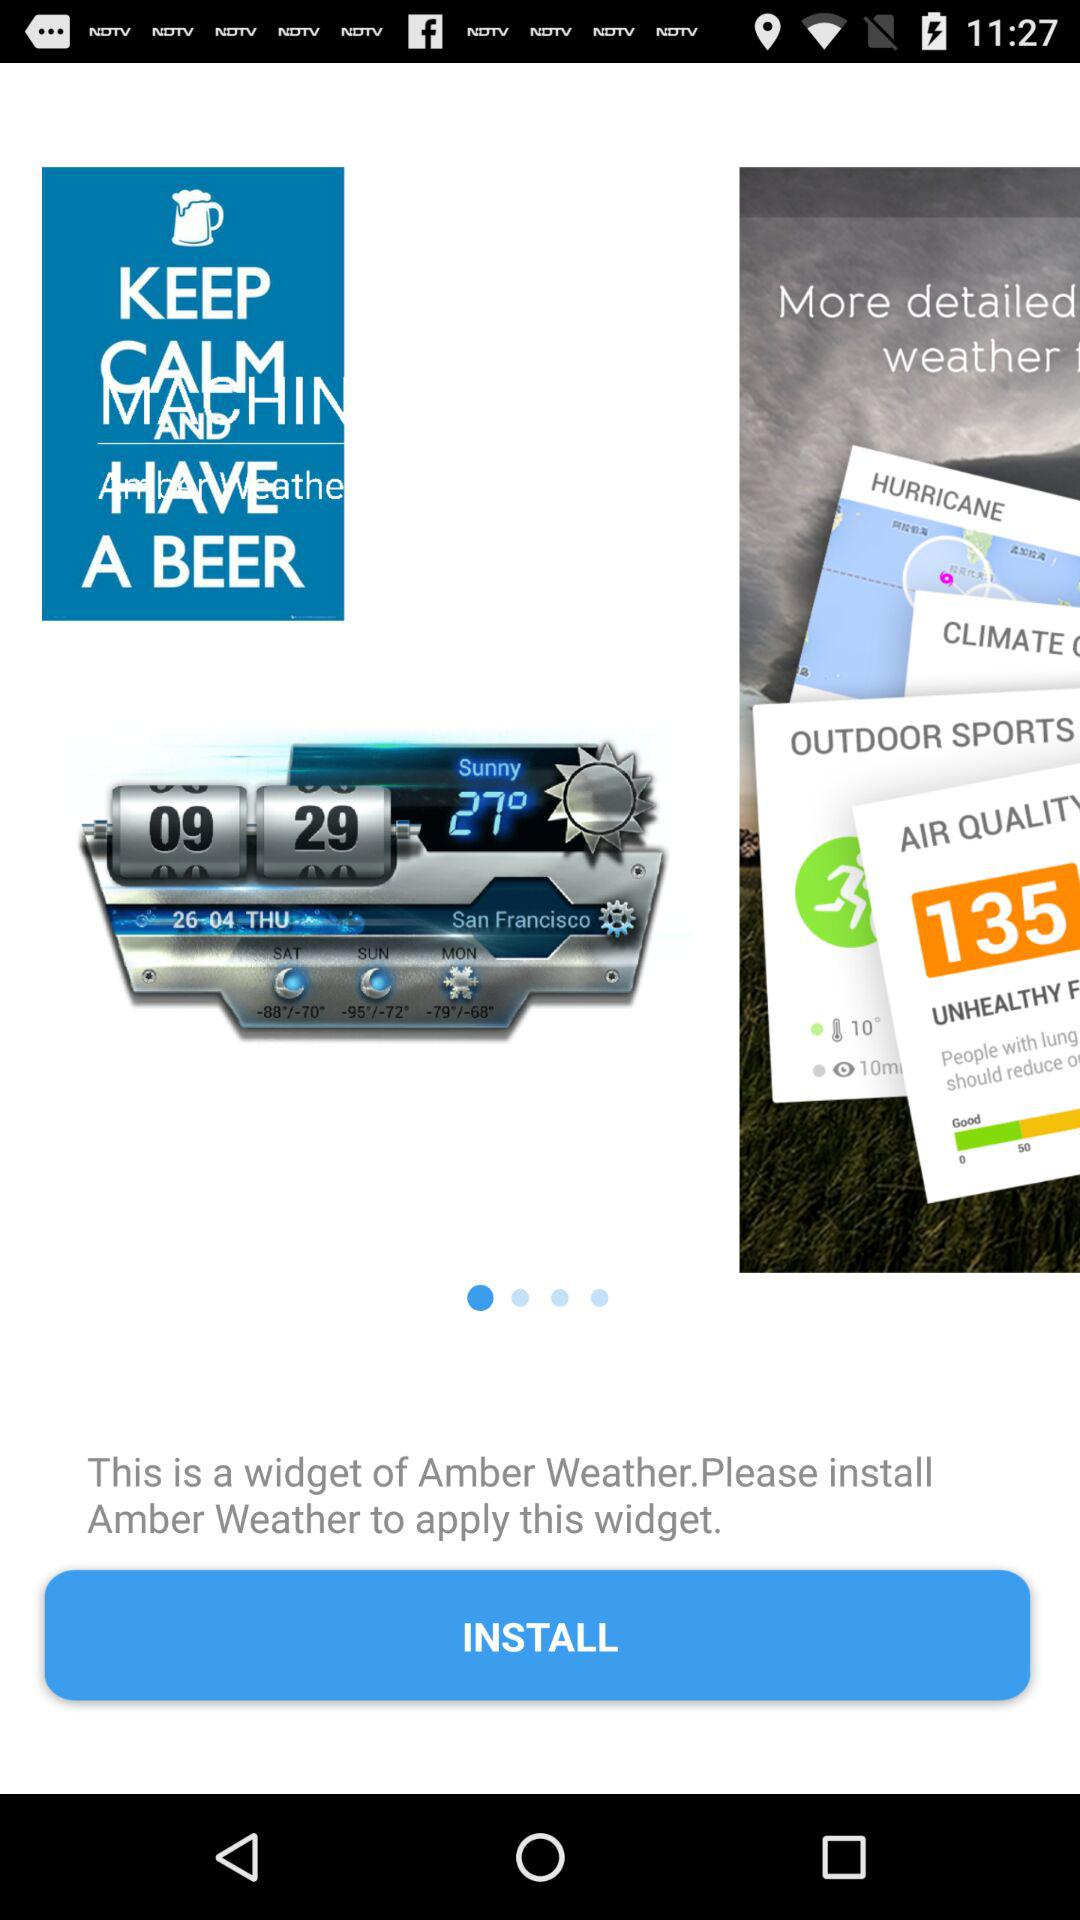What is the weather in "San Francisco"? The weather in "San Francisco" is "sunny". 